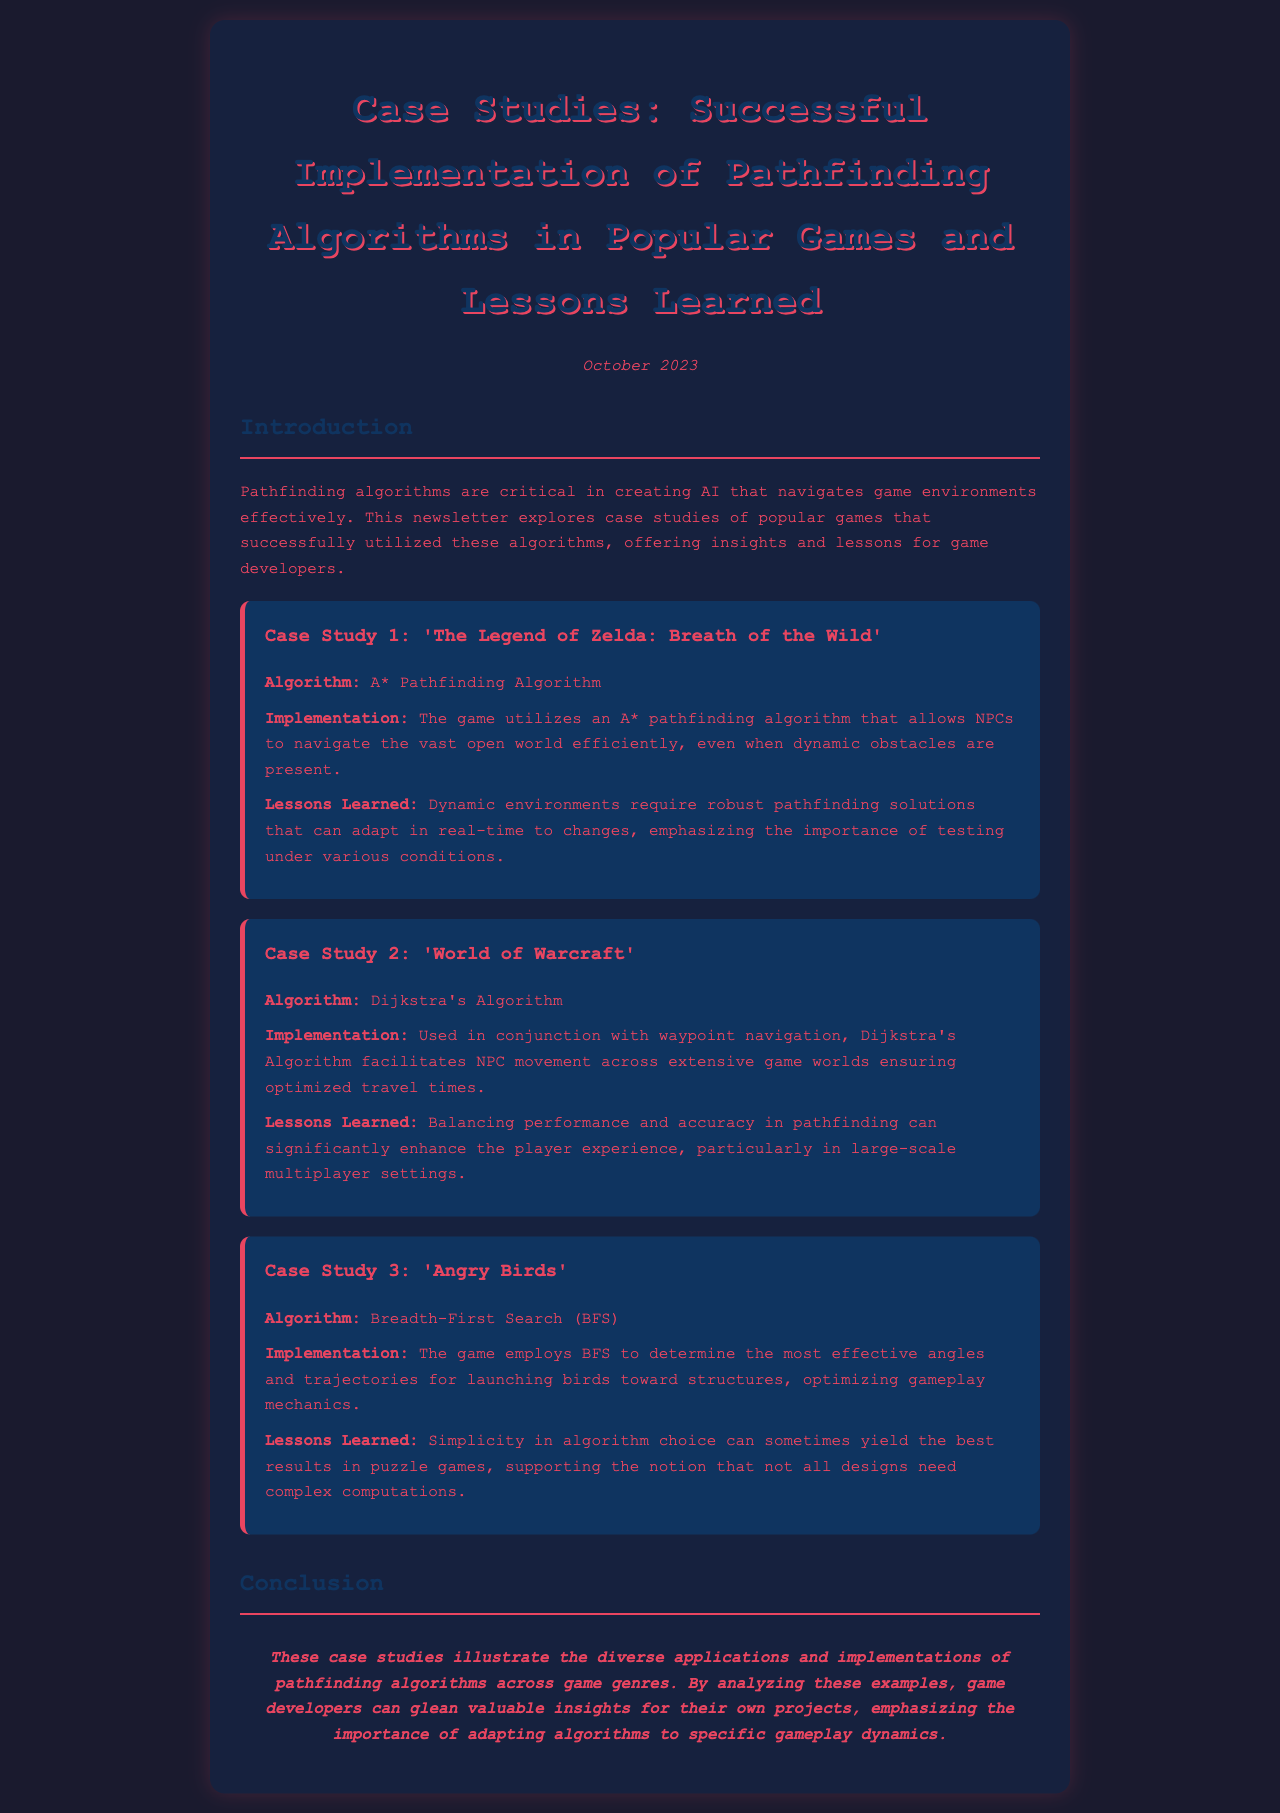what is the title of the newsletter? The title of the newsletter is given at the top of the document, which is "Case Studies: Successful Implementation of Pathfinding Algorithms in Popular Games and Lessons Learned."
Answer: Case Studies: Successful Implementation of Pathfinding Algorithms in Popular Games and Lessons Learned when was the newsletter published? The publication date is mentioned in the document, and it states that the newsletter was published in October 2023.
Answer: October 2023 what algorithm is used in 'The Legend of Zelda: Breath of the Wild'? The algorithm used in 'The Legend of Zelda: Breath of the Wild' is specified in the case study section, which states "A* Pathfinding Algorithm."
Answer: A* Pathfinding Algorithm which game uses Dijkstra's Algorithm? The document mentions that 'World of Warcraft' uses Dijkstra's Algorithm as part of its pathfinding strategy.
Answer: World of Warcraft what is a key lesson learned from 'Angry Birds'? The lessons learned section for 'Angry Birds' emphasizes simplicity in algorithm choice, indicating that sometimes simple algorithms yield the best results.
Answer: Simplicity in algorithm choice how does 'World of Warcraft' improve player experience? The document states that balancing performance and accuracy in pathfinding can enhance player experience, particularly in large-scale multiplayer settings.
Answer: Balancing performance and accuracy what trending topic does the newsletter focus on? The primary focus of the newsletter is on the implementation of pathfinding algorithms and their successful examples across popular games.
Answer: Pathfinding algorithms what type of environment challenges is highlighted in 'The Legend of Zelda: Breath of the Wild'? The case study for 'The Legend of Zelda: Breath of the Wild' mentions dynamic environments as a major challenge for the pathfinding solution.
Answer: Dynamic environments 